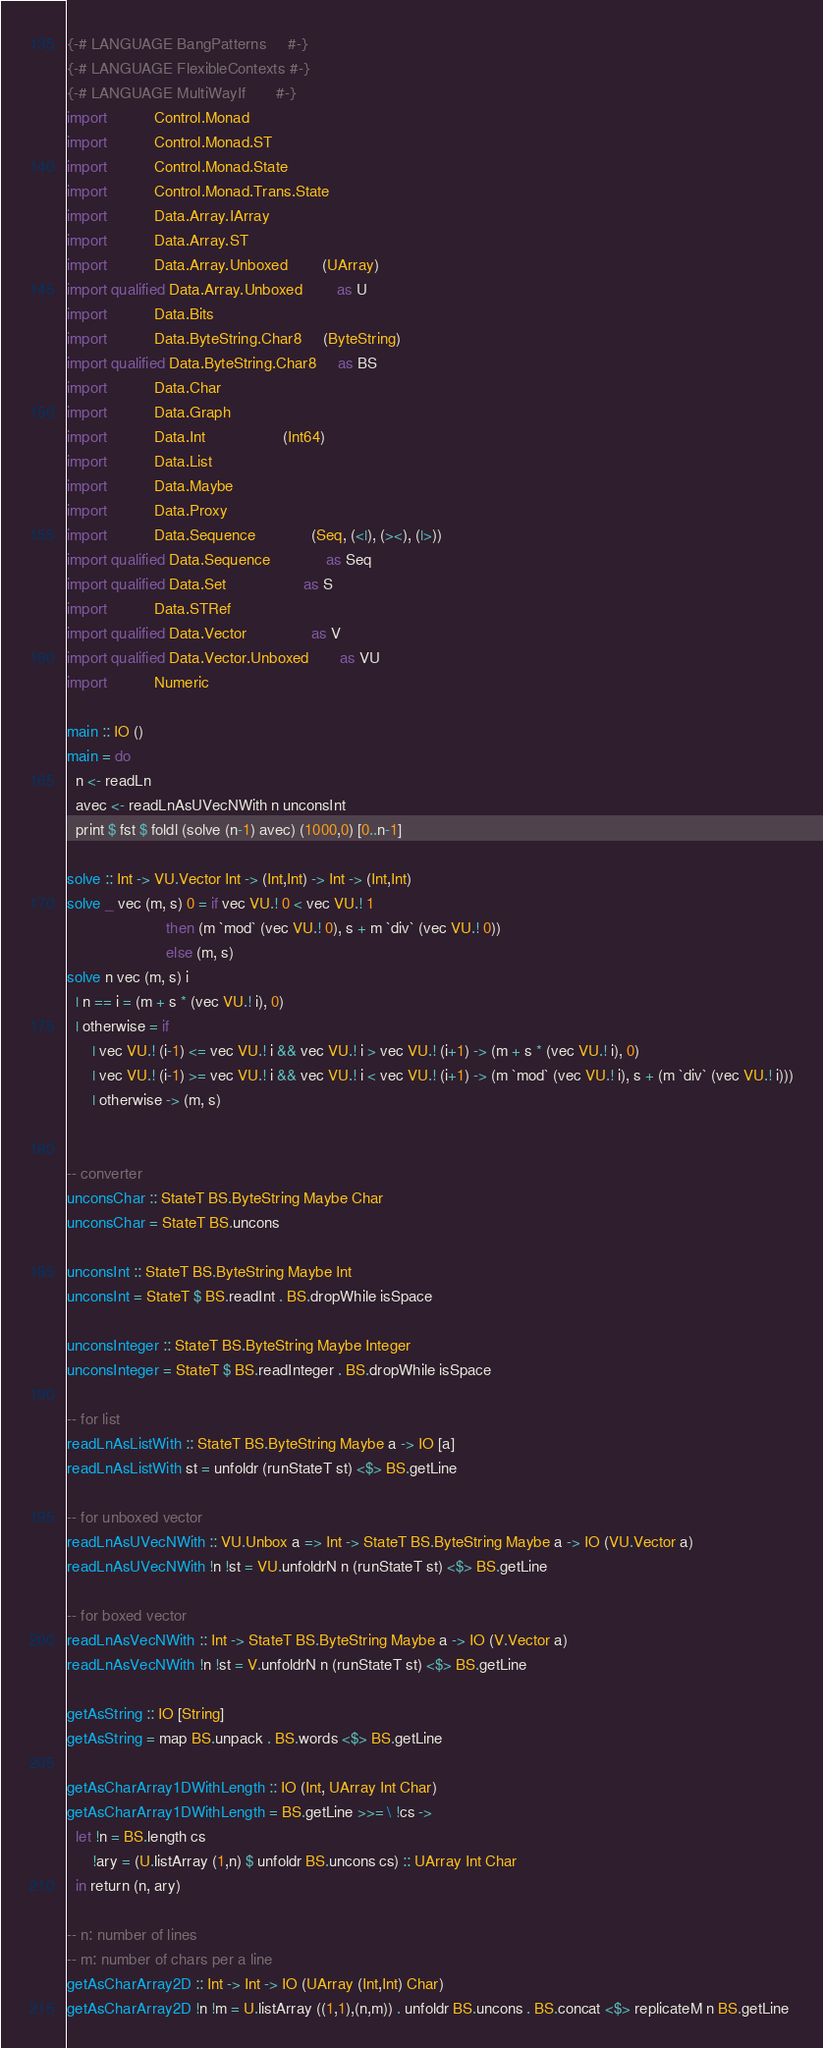Convert code to text. <code><loc_0><loc_0><loc_500><loc_500><_Haskell_>{-# LANGUAGE BangPatterns     #-}
{-# LANGUAGE FlexibleContexts #-}
{-# LANGUAGE MultiWayIf       #-}
import           Control.Monad
import           Control.Monad.ST
import           Control.Monad.State
import           Control.Monad.Trans.State
import           Data.Array.IArray
import           Data.Array.ST
import           Data.Array.Unboxed        (UArray)
import qualified Data.Array.Unboxed        as U
import           Data.Bits
import           Data.ByteString.Char8     (ByteString)
import qualified Data.ByteString.Char8     as BS
import           Data.Char
import           Data.Graph
import           Data.Int                  (Int64)
import           Data.List
import           Data.Maybe
import           Data.Proxy
import           Data.Sequence             (Seq, (<|), (><), (|>))
import qualified Data.Sequence             as Seq
import qualified Data.Set                  as S
import           Data.STRef
import qualified Data.Vector               as V
import qualified Data.Vector.Unboxed       as VU
import           Numeric

main :: IO ()
main = do
  n <- readLn
  avec <- readLnAsUVecNWith n unconsInt
  print $ fst $ foldl (solve (n-1) avec) (1000,0) [0..n-1]

solve :: Int -> VU.Vector Int -> (Int,Int) -> Int -> (Int,Int)
solve _ vec (m, s) 0 = if vec VU.! 0 < vec VU.! 1
                       then (m `mod` (vec VU.! 0), s + m `div` (vec VU.! 0))
                       else (m, s)
solve n vec (m, s) i
  | n == i = (m + s * (vec VU.! i), 0)
  | otherwise = if
      | vec VU.! (i-1) <= vec VU.! i && vec VU.! i > vec VU.! (i+1) -> (m + s * (vec VU.! i), 0)
      | vec VU.! (i-1) >= vec VU.! i && vec VU.! i < vec VU.! (i+1) -> (m `mod` (vec VU.! i), s + (m `div` (vec VU.! i)))
      | otherwise -> (m, s)


-- converter
unconsChar :: StateT BS.ByteString Maybe Char
unconsChar = StateT BS.uncons

unconsInt :: StateT BS.ByteString Maybe Int
unconsInt = StateT $ BS.readInt . BS.dropWhile isSpace

unconsInteger :: StateT BS.ByteString Maybe Integer
unconsInteger = StateT $ BS.readInteger . BS.dropWhile isSpace

-- for list
readLnAsListWith :: StateT BS.ByteString Maybe a -> IO [a]
readLnAsListWith st = unfoldr (runStateT st) <$> BS.getLine

-- for unboxed vector
readLnAsUVecNWith :: VU.Unbox a => Int -> StateT BS.ByteString Maybe a -> IO (VU.Vector a)
readLnAsUVecNWith !n !st = VU.unfoldrN n (runStateT st) <$> BS.getLine

-- for boxed vector
readLnAsVecNWith :: Int -> StateT BS.ByteString Maybe a -> IO (V.Vector a)
readLnAsVecNWith !n !st = V.unfoldrN n (runStateT st) <$> BS.getLine

getAsString :: IO [String]
getAsString = map BS.unpack . BS.words <$> BS.getLine

getAsCharArray1DWithLength :: IO (Int, UArray Int Char)
getAsCharArray1DWithLength = BS.getLine >>= \ !cs ->
  let !n = BS.length cs
      !ary = (U.listArray (1,n) $ unfoldr BS.uncons cs) :: UArray Int Char
  in return (n, ary)

-- n: number of lines
-- m: number of chars per a line
getAsCharArray2D :: Int -> Int -> IO (UArray (Int,Int) Char)
getAsCharArray2D !n !m = U.listArray ((1,1),(n,m)) . unfoldr BS.uncons . BS.concat <$> replicateM n BS.getLine
</code> 